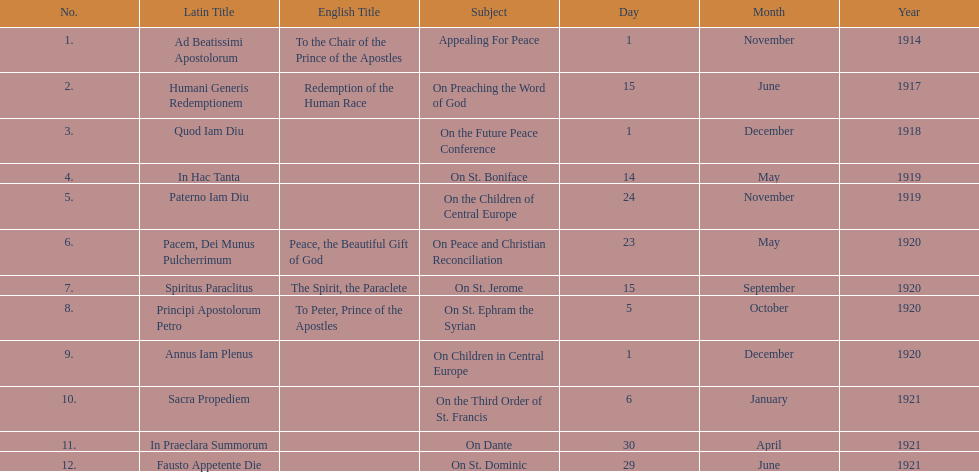What was the number of encyclopedias that had subjects relating specifically to children? 2. 